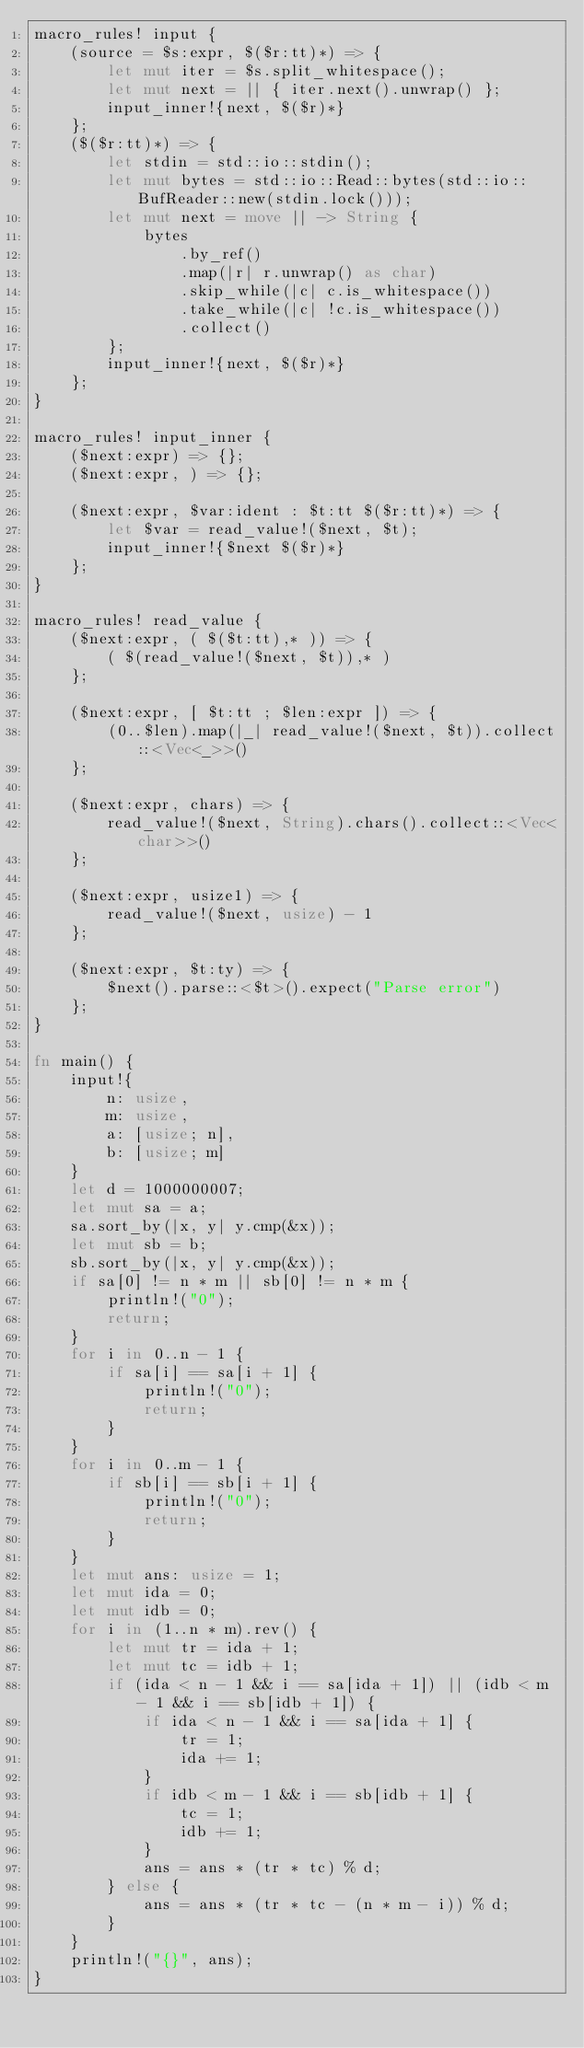<code> <loc_0><loc_0><loc_500><loc_500><_Rust_>macro_rules! input {
    (source = $s:expr, $($r:tt)*) => {
        let mut iter = $s.split_whitespace();
        let mut next = || { iter.next().unwrap() };
        input_inner!{next, $($r)*}
    };
    ($($r:tt)*) => {
        let stdin = std::io::stdin();
        let mut bytes = std::io::Read::bytes(std::io::BufReader::new(stdin.lock()));
        let mut next = move || -> String {
            bytes
                .by_ref()
                .map(|r| r.unwrap() as char)
                .skip_while(|c| c.is_whitespace())
                .take_while(|c| !c.is_whitespace())
                .collect()
        };
        input_inner!{next, $($r)*}
    };
}

macro_rules! input_inner {
    ($next:expr) => {};
    ($next:expr, ) => {};

    ($next:expr, $var:ident : $t:tt $($r:tt)*) => {
        let $var = read_value!($next, $t);
        input_inner!{$next $($r)*}
    };
}

macro_rules! read_value {
    ($next:expr, ( $($t:tt),* )) => {
        ( $(read_value!($next, $t)),* )
    };

    ($next:expr, [ $t:tt ; $len:expr ]) => {
        (0..$len).map(|_| read_value!($next, $t)).collect::<Vec<_>>()
    };

    ($next:expr, chars) => {
        read_value!($next, String).chars().collect::<Vec<char>>()
    };

    ($next:expr, usize1) => {
        read_value!($next, usize) - 1
    };

    ($next:expr, $t:ty) => {
        $next().parse::<$t>().expect("Parse error")
    };
}

fn main() {
    input!{
        n: usize,
        m: usize,
        a: [usize; n],
        b: [usize; m]
    }
    let d = 1000000007;
    let mut sa = a;
    sa.sort_by(|x, y| y.cmp(&x));
    let mut sb = b;
    sb.sort_by(|x, y| y.cmp(&x));
    if sa[0] != n * m || sb[0] != n * m {
        println!("0");
        return;
    }
    for i in 0..n - 1 {
        if sa[i] == sa[i + 1] {
            println!("0");
            return;
        }
    }
    for i in 0..m - 1 {
        if sb[i] == sb[i + 1] {
            println!("0");
            return;
        }
    }
    let mut ans: usize = 1;
    let mut ida = 0;
    let mut idb = 0;
    for i in (1..n * m).rev() {
        let mut tr = ida + 1;
        let mut tc = idb + 1;
        if (ida < n - 1 && i == sa[ida + 1]) || (idb < m - 1 && i == sb[idb + 1]) {
            if ida < n - 1 && i == sa[ida + 1] {
                tr = 1;
                ida += 1;
            }
            if idb < m - 1 && i == sb[idb + 1] {
                tc = 1;
                idb += 1;
            }
            ans = ans * (tr * tc) % d;
        } else {
            ans = ans * (tr * tc - (n * m - i)) % d;
        }
    }
    println!("{}", ans);
}
</code> 